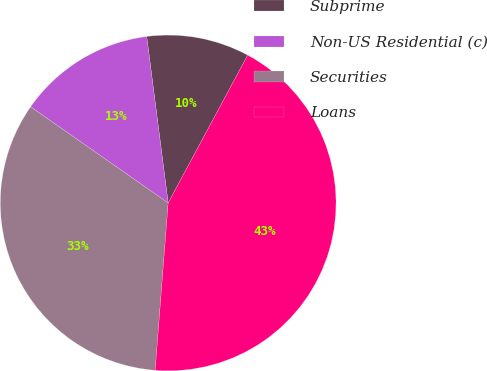Convert chart. <chart><loc_0><loc_0><loc_500><loc_500><pie_chart><fcel>Subprime<fcel>Non-US Residential (c)<fcel>Securities<fcel>Loans<nl><fcel>9.9%<fcel>13.25%<fcel>33.48%<fcel>43.38%<nl></chart> 